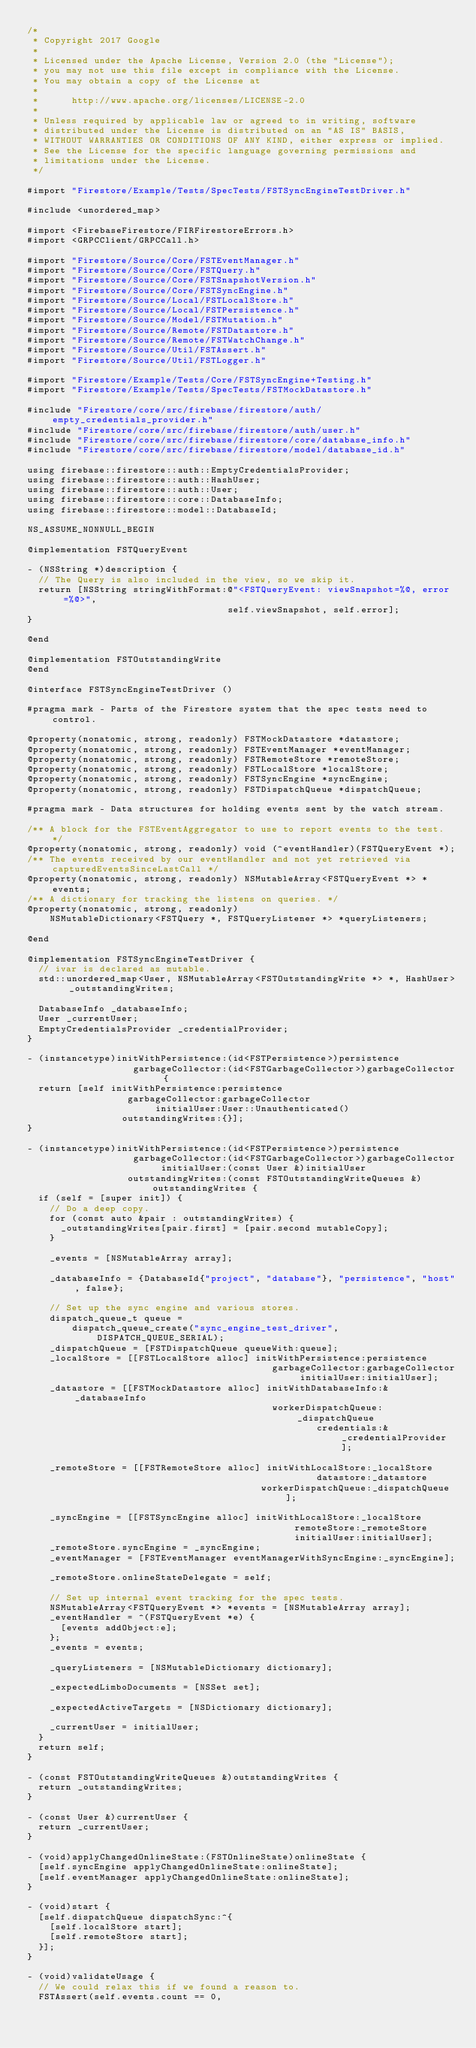Convert code to text. <code><loc_0><loc_0><loc_500><loc_500><_ObjectiveC_>/*
 * Copyright 2017 Google
 *
 * Licensed under the Apache License, Version 2.0 (the "License");
 * you may not use this file except in compliance with the License.
 * You may obtain a copy of the License at
 *
 *      http://www.apache.org/licenses/LICENSE-2.0
 *
 * Unless required by applicable law or agreed to in writing, software
 * distributed under the License is distributed on an "AS IS" BASIS,
 * WITHOUT WARRANTIES OR CONDITIONS OF ANY KIND, either express or implied.
 * See the License for the specific language governing permissions and
 * limitations under the License.
 */

#import "Firestore/Example/Tests/SpecTests/FSTSyncEngineTestDriver.h"

#include <unordered_map>

#import <FirebaseFirestore/FIRFirestoreErrors.h>
#import <GRPCClient/GRPCCall.h>

#import "Firestore/Source/Core/FSTEventManager.h"
#import "Firestore/Source/Core/FSTQuery.h"
#import "Firestore/Source/Core/FSTSnapshotVersion.h"
#import "Firestore/Source/Core/FSTSyncEngine.h"
#import "Firestore/Source/Local/FSTLocalStore.h"
#import "Firestore/Source/Local/FSTPersistence.h"
#import "Firestore/Source/Model/FSTMutation.h"
#import "Firestore/Source/Remote/FSTDatastore.h"
#import "Firestore/Source/Remote/FSTWatchChange.h"
#import "Firestore/Source/Util/FSTAssert.h"
#import "Firestore/Source/Util/FSTLogger.h"

#import "Firestore/Example/Tests/Core/FSTSyncEngine+Testing.h"
#import "Firestore/Example/Tests/SpecTests/FSTMockDatastore.h"

#include "Firestore/core/src/firebase/firestore/auth/empty_credentials_provider.h"
#include "Firestore/core/src/firebase/firestore/auth/user.h"
#include "Firestore/core/src/firebase/firestore/core/database_info.h"
#include "Firestore/core/src/firebase/firestore/model/database_id.h"

using firebase::firestore::auth::EmptyCredentialsProvider;
using firebase::firestore::auth::HashUser;
using firebase::firestore::auth::User;
using firebase::firestore::core::DatabaseInfo;
using firebase::firestore::model::DatabaseId;

NS_ASSUME_NONNULL_BEGIN

@implementation FSTQueryEvent

- (NSString *)description {
  // The Query is also included in the view, so we skip it.
  return [NSString stringWithFormat:@"<FSTQueryEvent: viewSnapshot=%@, error=%@>",
                                    self.viewSnapshot, self.error];
}

@end

@implementation FSTOutstandingWrite
@end

@interface FSTSyncEngineTestDriver ()

#pragma mark - Parts of the Firestore system that the spec tests need to control.

@property(nonatomic, strong, readonly) FSTMockDatastore *datastore;
@property(nonatomic, strong, readonly) FSTEventManager *eventManager;
@property(nonatomic, strong, readonly) FSTRemoteStore *remoteStore;
@property(nonatomic, strong, readonly) FSTLocalStore *localStore;
@property(nonatomic, strong, readonly) FSTSyncEngine *syncEngine;
@property(nonatomic, strong, readonly) FSTDispatchQueue *dispatchQueue;

#pragma mark - Data structures for holding events sent by the watch stream.

/** A block for the FSTEventAggregator to use to report events to the test. */
@property(nonatomic, strong, readonly) void (^eventHandler)(FSTQueryEvent *);
/** The events received by our eventHandler and not yet retrieved via capturedEventsSinceLastCall */
@property(nonatomic, strong, readonly) NSMutableArray<FSTQueryEvent *> *events;
/** A dictionary for tracking the listens on queries. */
@property(nonatomic, strong, readonly)
    NSMutableDictionary<FSTQuery *, FSTQueryListener *> *queryListeners;

@end

@implementation FSTSyncEngineTestDriver {
  // ivar is declared as mutable.
  std::unordered_map<User, NSMutableArray<FSTOutstandingWrite *> *, HashUser> _outstandingWrites;

  DatabaseInfo _databaseInfo;
  User _currentUser;
  EmptyCredentialsProvider _credentialProvider;
}

- (instancetype)initWithPersistence:(id<FSTPersistence>)persistence
                   garbageCollector:(id<FSTGarbageCollector>)garbageCollector {
  return [self initWithPersistence:persistence
                  garbageCollector:garbageCollector
                       initialUser:User::Unauthenticated()
                 outstandingWrites:{}];
}

- (instancetype)initWithPersistence:(id<FSTPersistence>)persistence
                   garbageCollector:(id<FSTGarbageCollector>)garbageCollector
                        initialUser:(const User &)initialUser
                  outstandingWrites:(const FSTOutstandingWriteQueues &)outstandingWrites {
  if (self = [super init]) {
    // Do a deep copy.
    for (const auto &pair : outstandingWrites) {
      _outstandingWrites[pair.first] = [pair.second mutableCopy];
    }

    _events = [NSMutableArray array];

    _databaseInfo = {DatabaseId{"project", "database"}, "persistence", "host", false};

    // Set up the sync engine and various stores.
    dispatch_queue_t queue =
        dispatch_queue_create("sync_engine_test_driver", DISPATCH_QUEUE_SERIAL);
    _dispatchQueue = [FSTDispatchQueue queueWith:queue];
    _localStore = [[FSTLocalStore alloc] initWithPersistence:persistence
                                            garbageCollector:garbageCollector
                                                 initialUser:initialUser];
    _datastore = [[FSTMockDatastore alloc] initWithDatabaseInfo:&_databaseInfo
                                            workerDispatchQueue:_dispatchQueue
                                                    credentials:&_credentialProvider];

    _remoteStore = [[FSTRemoteStore alloc] initWithLocalStore:_localStore
                                                    datastore:_datastore
                                          workerDispatchQueue:_dispatchQueue];

    _syncEngine = [[FSTSyncEngine alloc] initWithLocalStore:_localStore
                                                remoteStore:_remoteStore
                                                initialUser:initialUser];
    _remoteStore.syncEngine = _syncEngine;
    _eventManager = [FSTEventManager eventManagerWithSyncEngine:_syncEngine];

    _remoteStore.onlineStateDelegate = self;

    // Set up internal event tracking for the spec tests.
    NSMutableArray<FSTQueryEvent *> *events = [NSMutableArray array];
    _eventHandler = ^(FSTQueryEvent *e) {
      [events addObject:e];
    };
    _events = events;

    _queryListeners = [NSMutableDictionary dictionary];

    _expectedLimboDocuments = [NSSet set];

    _expectedActiveTargets = [NSDictionary dictionary];

    _currentUser = initialUser;
  }
  return self;
}

- (const FSTOutstandingWriteQueues &)outstandingWrites {
  return _outstandingWrites;
}

- (const User &)currentUser {
  return _currentUser;
}

- (void)applyChangedOnlineState:(FSTOnlineState)onlineState {
  [self.syncEngine applyChangedOnlineState:onlineState];
  [self.eventManager applyChangedOnlineState:onlineState];
}

- (void)start {
  [self.dispatchQueue dispatchSync:^{
    [self.localStore start];
    [self.remoteStore start];
  }];
}

- (void)validateUsage {
  // We could relax this if we found a reason to.
  FSTAssert(self.events.count == 0,</code> 